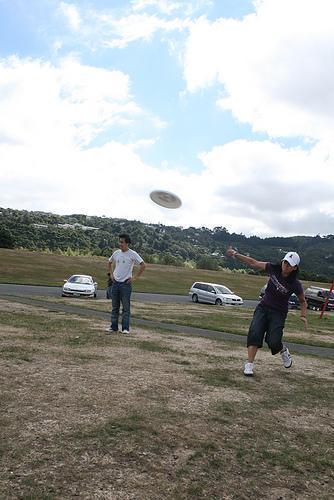How many men are in the photo?
Give a very brief answer. 2. 